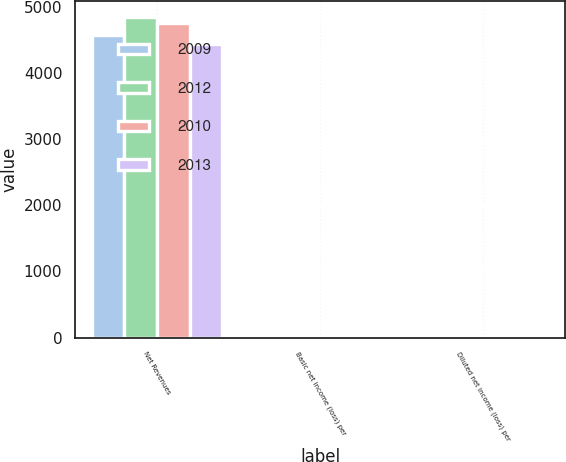<chart> <loc_0><loc_0><loc_500><loc_500><stacked_bar_chart><ecel><fcel>Net Revenues<fcel>Basic net income (loss) per<fcel>Diluted net income (loss) per<nl><fcel>2009<fcel>4583<fcel>0.96<fcel>0.95<nl><fcel>2012<fcel>4856<fcel>1.01<fcel>1.01<nl><fcel>2010<fcel>4755<fcel>0.93<fcel>0.92<nl><fcel>2013<fcel>4447<fcel>0.34<fcel>0.33<nl></chart> 